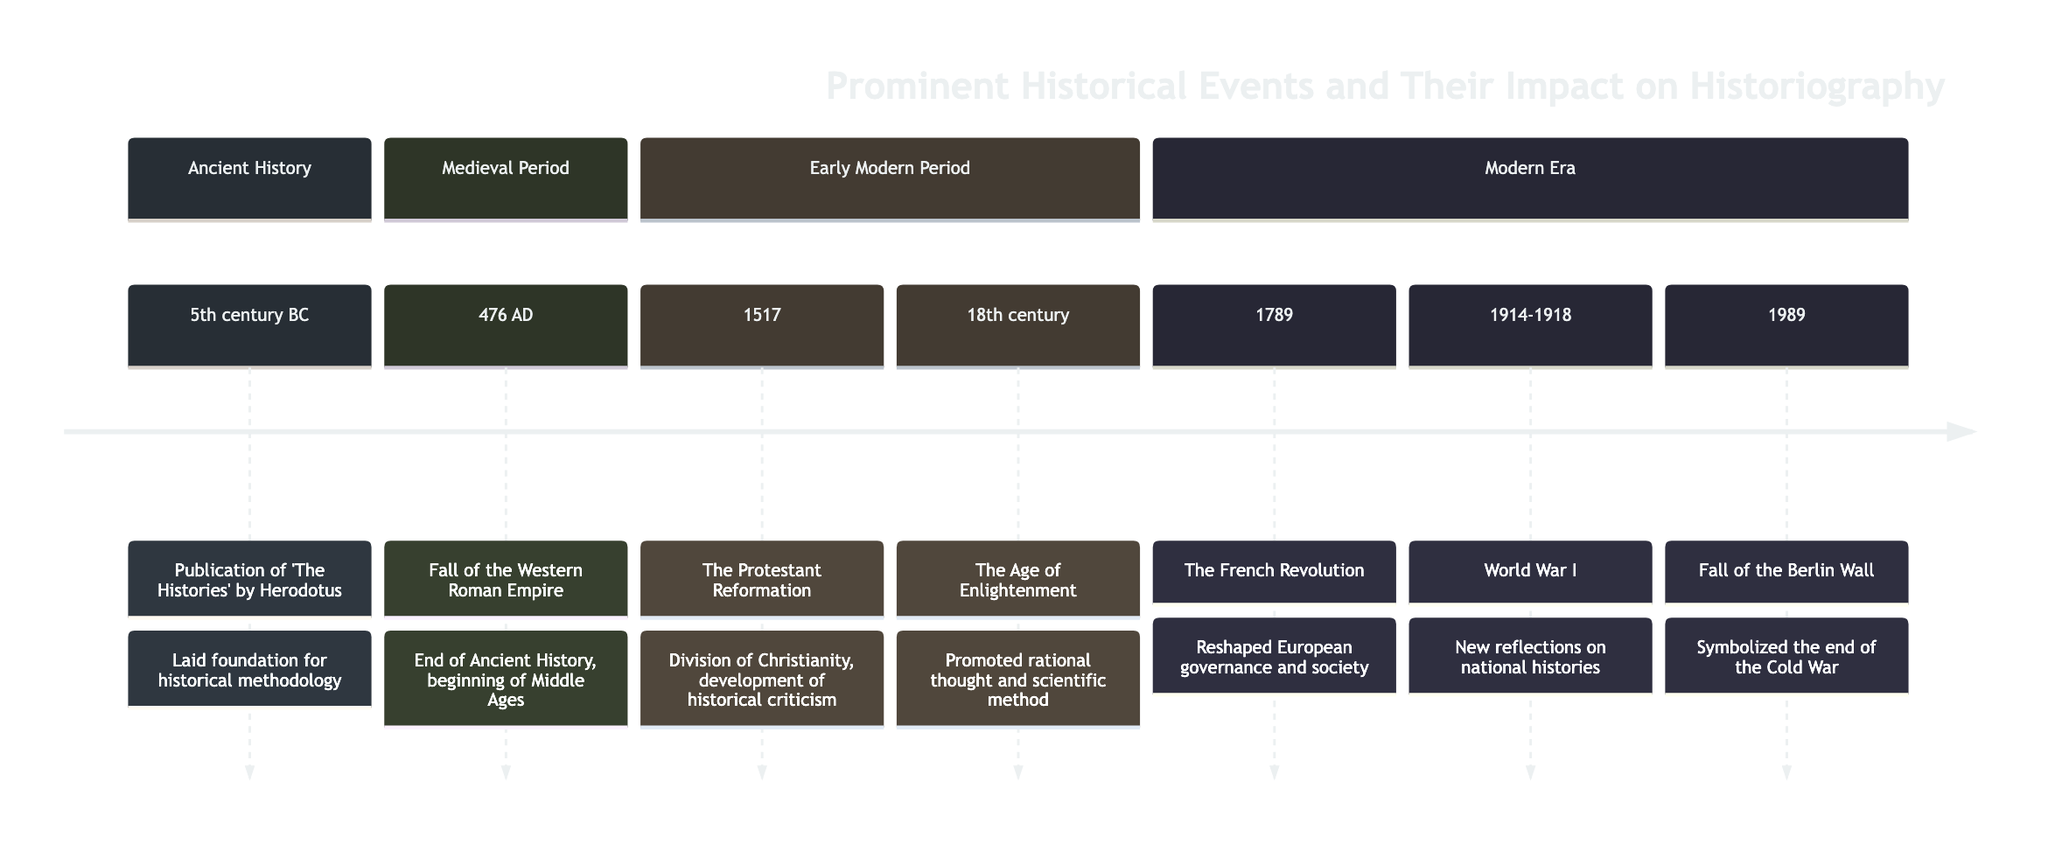What is the earliest event recorded in the timeline? The timeline lists events starting from "5th century BC". By identifying the earliest date, we see that it is the publication of 'The Histories' by Herodotus, which is recognized as the foundational event for historiography.
Answer: 5th century BC How many events are listed in the timeline? To determine the number of events, we can count each individual entry in the timeline elements provided. There are a total of 7 events listed.
Answer: 7 What impact did the Protestant Reformation have on historiography? The impact of the Protestant Reformation is stated as leading to the division of Christianity and the development of historical criticism. This can be identified directly from the specific entry in the timeline.
Answer: Division of Christianity, development of historical criticism What event took place in 1789? By examining the timeline, we find that the event listed for 1789 is the French Revolution. This is clearly indicated in the corresponding section of the timeline.
Answer: The French Revolution Which event symbolizes the end of the Cold War? The timeline states that the Fall of the Berlin Wall in 1989 symbolizes the end of the Cold War. This is noted under the Modern Era section.
Answer: Fall of the Berlin Wall Which historical period does the Age of Enlightenment belong to? The Age of Enlightenment is indicated as part of the Early Modern Period within the timeline. This classification can be determined by looking at the corresponding section heading.
Answer: Early Modern Period What important change in historiography occurred during the Age of Enlightenment? The timeline specifies that the Age of Enlightenment promoted rational thought and scientific method, which had a significant impact on historiography. This is derived from the specific impact noted in that section.
Answer: Rational thought and scientific method What period followed the Fall of the Western Roman Empire? The timeline directly indicates that the period following the Fall of the Western Roman Empire, which occurred in 476 AD, is the Middle Ages, marking a historical transition.
Answer: Middle Ages 